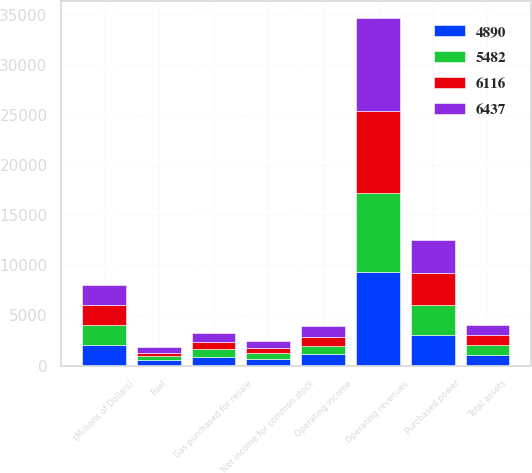Convert chart. <chart><loc_0><loc_0><loc_500><loc_500><stacked_bar_chart><ecel><fcel>(Millions of Dollars)<fcel>Operating revenues<fcel>Purchased power<fcel>Fuel<fcel>Gas purchased for resale<fcel>Operating income<fcel>Net income for common stock<fcel>Total assets<nl><fcel>4890<fcel>2006<fcel>9288<fcel>3052<fcel>525<fcel>902<fcel>1110<fcel>686<fcel>1003<nl><fcel>6437<fcel>2005<fcel>9227<fcel>3322<fcel>526<fcel>965<fcel>1041<fcel>694<fcel>1003<nl><fcel>5482<fcel>2004<fcel>7971<fcel>3029<fcel>404<fcel>709<fcel>825<fcel>518<fcel>1003<nl><fcel>6116<fcel>2003<fcel>8166<fcel>3124<fcel>358<fcel>715<fcel>942<fcel>591<fcel>1003<nl></chart> 